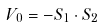Convert formula to latex. <formula><loc_0><loc_0><loc_500><loc_500>V _ { 0 } = - { S } _ { 1 } \cdot { S } _ { 2 }</formula> 